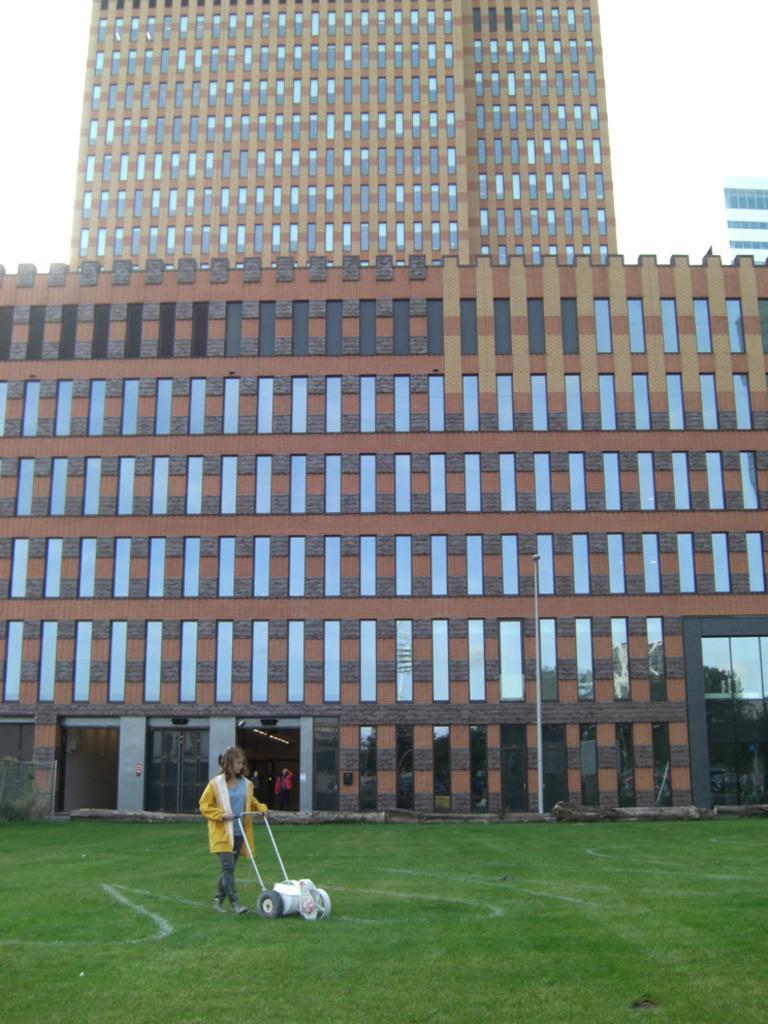In one or two sentences, can you explain what this image depicts? In this picture I can observe building in the middle of the picture. In front of the building there is a person. The person is holding a lawn mower in her hands. In the background I can observe sky. 